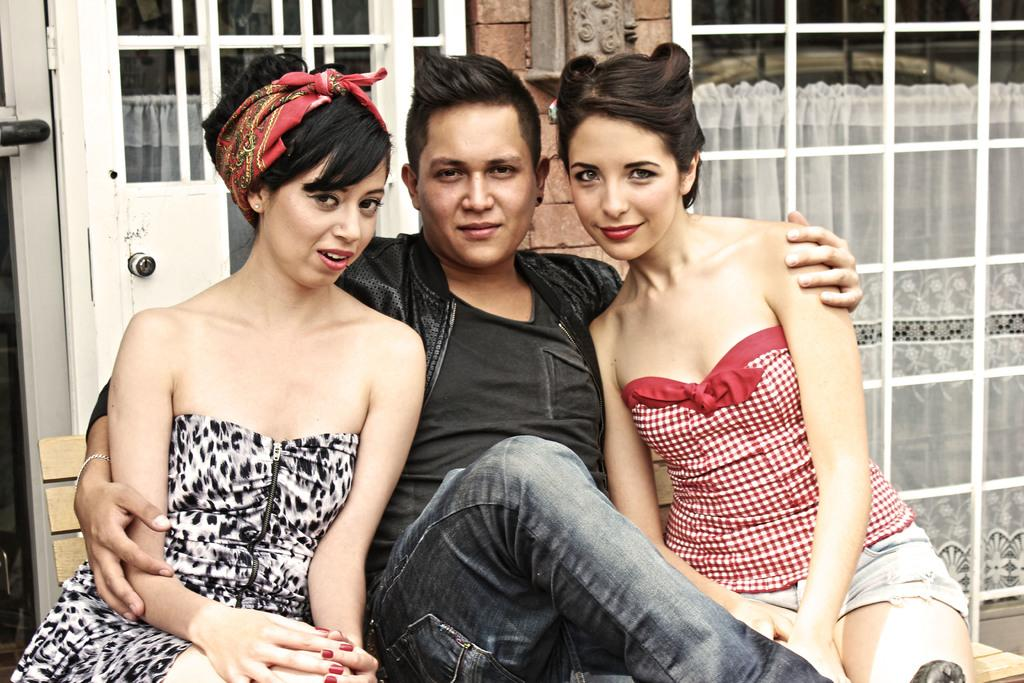Who or what is present in the image? There are people in the image. Can you describe the background of the image? There is a white cloth in the background of the image. What type of alarm is ringing in the image? There is no alarm present in the image. Is there a crown visible on anyone's head in the image? There is no crown visible in the image. 